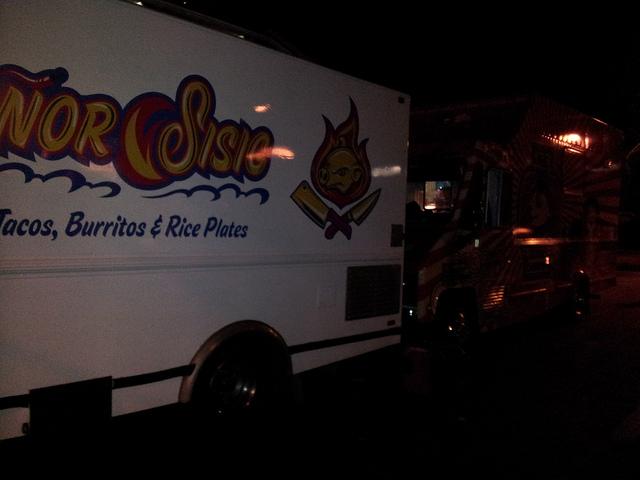Is this a mobile restaurant?
Concise answer only. Yes. What does the wall say?
Be succinct. No sitio. What are the letters on the trucks?
Answer briefly. No sitio. What color is the truck?
Write a very short answer. White. What kind of food does this truck have?
Write a very short answer. Mexican. Was this picture taken at night?
Keep it brief. Yes. Where are the letters located?
Concise answer only. Truck. What is Bristol?
Write a very short answer. Food truck. What time of day is this?
Write a very short answer. Night. When would a person normally eat this pastry?
Be succinct. Lunch. What kind of vehicle is this?
Give a very brief answer. Truck. Is this a loft?
Answer briefly. No. Are there any windows?
Keep it brief. No. 